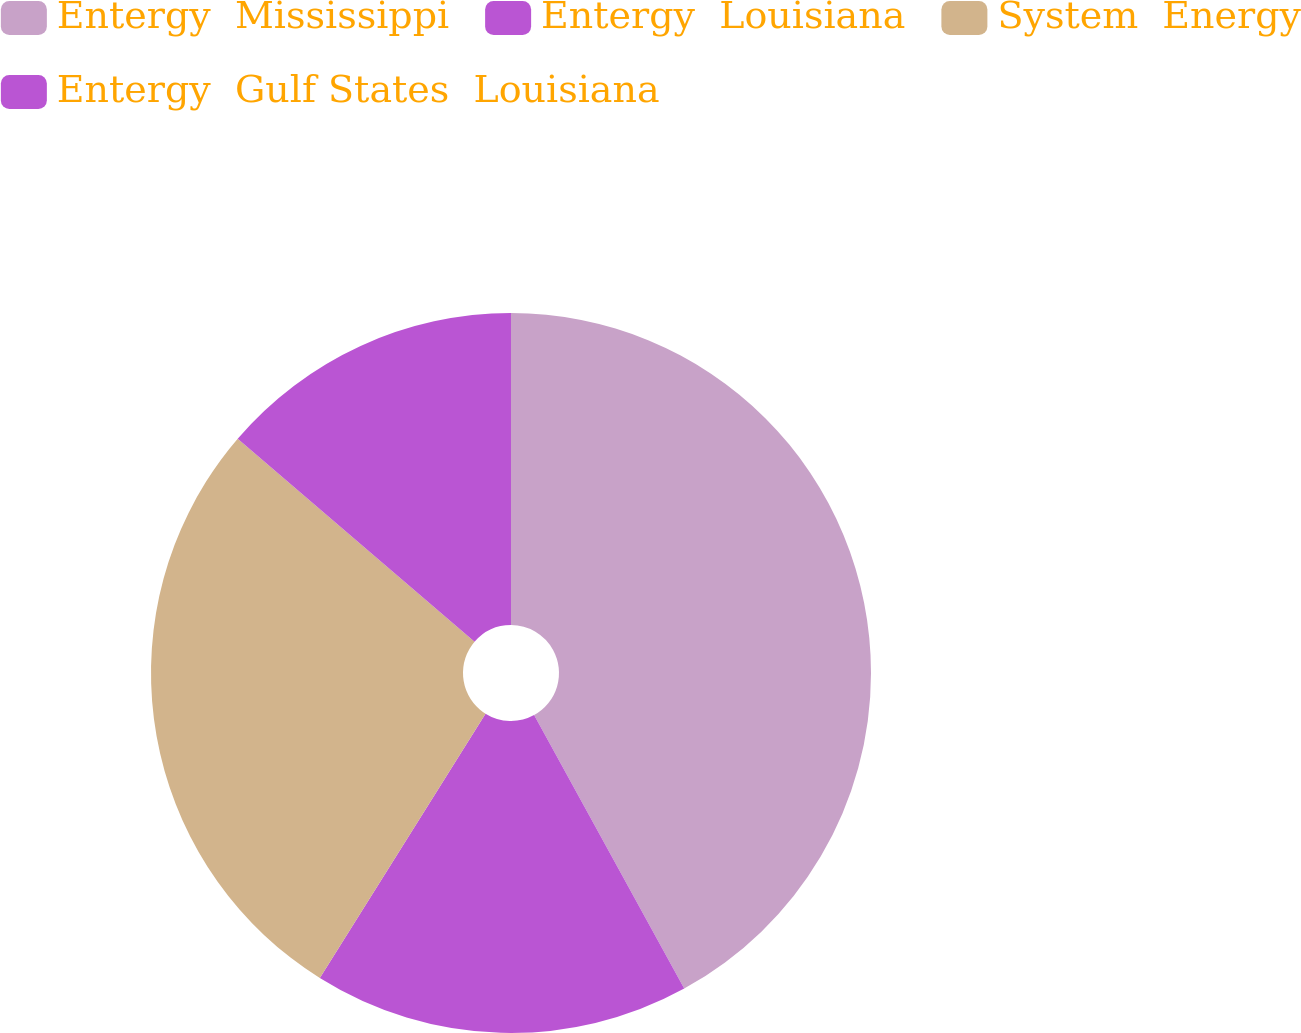Convert chart. <chart><loc_0><loc_0><loc_500><loc_500><pie_chart><fcel>Entergy  Mississippi<fcel>Entergy  Louisiana<fcel>System  Energy<fcel>Entergy  Gulf States  Louisiana<nl><fcel>42.01%<fcel>16.9%<fcel>27.37%<fcel>13.72%<nl></chart> 